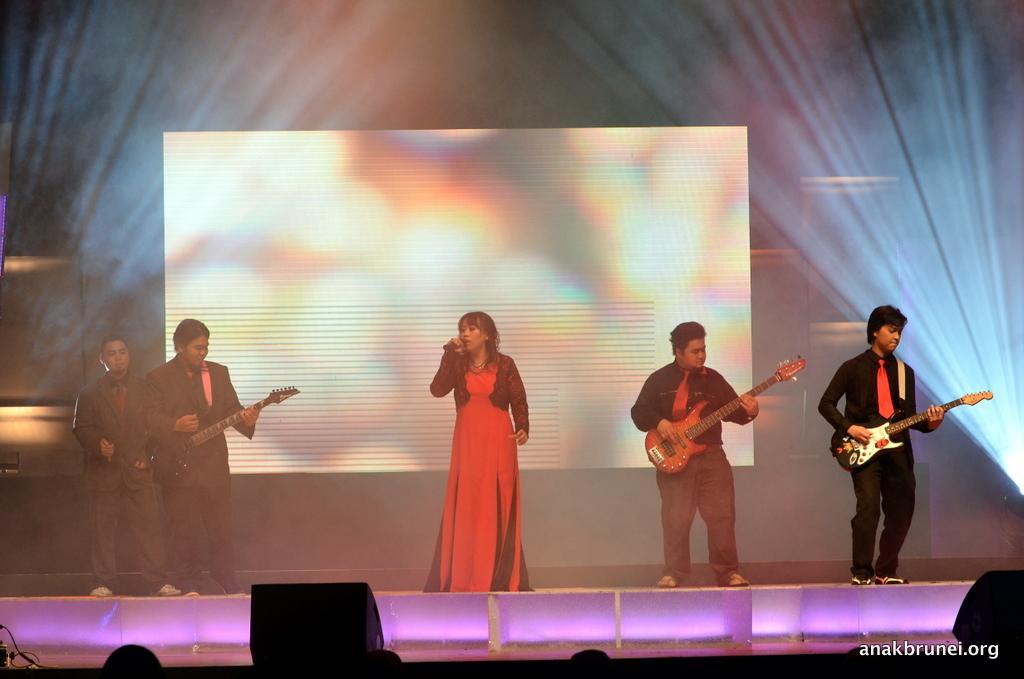Could you give a brief overview of what you see in this image? In this image we can see a group of people standing on stage. One woman is holding a microphone in her hand. Some persons are holding guitars. In the background, we can see the speakers. In the background, we can see some lights and screen. At the bottom we can see some text. 